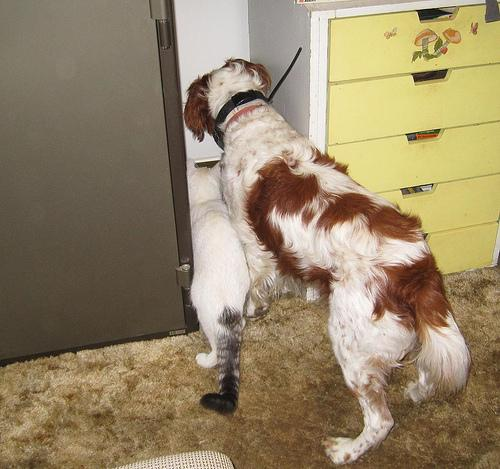How many subjects are there and what are they? Two subjects are present, a dog and a cat. Provide a brief summary of the main subjects in the image. A dog and cat play together on a tan and brown carpet, in a room with a grey door, yellow chest of drawers, and a hinge on the door. Enumerate three prominent colors in the image and the objects they are associated with. Yellow - drawers in chest, Grey - door on the room, Brown - patches of fur on the back of the white dog. What type of floor covering is in the image, and what are its colors? A tan and brown carpet is on the floor. What is the primary interaction between the two main subjects in the image? The primary interaction is that the dog and cat are playing together. Describe any interesting decoration on the chest of drawers. Mushrooms and butterfly designs can be seen on the fr Are the yellow drawers placed on top of a black table? The image describes yellow drawers in a chest and their position, but there is no mention of any furniture, such as a black table on which they might be placed. Tell me the emotions conveyed in this image. Playfulness, curiosity, and comfort. Can you find a red ball on the tan and brown carpet? No, it's not mentioned in the image. Given the image data, which object is associated with the phrase "mushrooms and butterfly designs"? Yellow chest of drawers. Identify attributes of the dog in the image. Medium size, white fur, brown patches, floppy brown ear, black collar List the textual information present in the image. There is no text present in the image. Describe the interaction between the dog and the cat. The dog and the cat are playing together, standing in front of an opening in the wall. Is the cat's paw holding a small toy? The image provides detailed information about the cat's various body parts, including its paws, but there is no mention of it holding a small toy or any other items. Does the grey door have a colorful pattern on it? The image describes a grey door without mentioning any patterns or decorations on it, so the existence of a colorful pattern is misleading. Identify any anomalies or unusual aspects in this image. No significant anomalies or unusual aspects detected. 